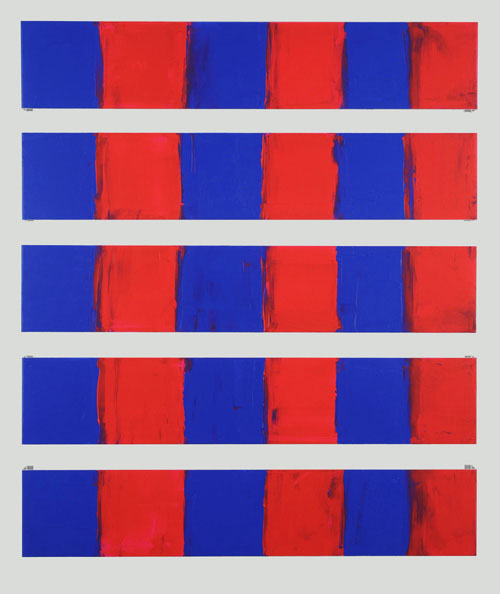Imagine this image depicts a scene from another planet. Describe that scene and the environment in detail. On a distant planet far from Earth, these rectangular structures could be immense monoliths arranged by an ancient civilization. The red and blue hues could come from the natural pigments present in the planet's unique flora and fauna. The red-painted sections might glow with a bioluminescent quality at night, while the blue areas absorb and reflect the serene light of two moons. The inhabitants of this alien world might view these monoliths as sacred, making pilgrimages to them during specific celestial events when the colors interact with the atmosphere, creating breathtaking light displays. The landscape surrounding these monoliths is lush, with bioluminescent plants and strange, yet beautiful, hybrid creatures that look like a mix between terrestrial mammals and marine life. How do the extraterrestrial beings interact with these monoliths? The extraterrestrial beings on this planet have a deep spiritual connection with the monoliths. These sentient beings, resembling luminescent figures themselves, commune with the monoliths during ritualistic ceremonies. During these gatherings, they arrange themselves in symmetric patterns around the structures, creating an intricate dance that mirrors the grid-like pattern of the monolith arrangement. Their chants resonate with the colors, causing the red and blue sections to pulsate harmoniously. This interaction is believed to be a way of maintaining cosmic balance, ensuring the ongoing fertility and prosperity of their environment. The monoliths serve as focal points for their society’s cultural and spiritual life, embodying the unity and duality that define their existence. 